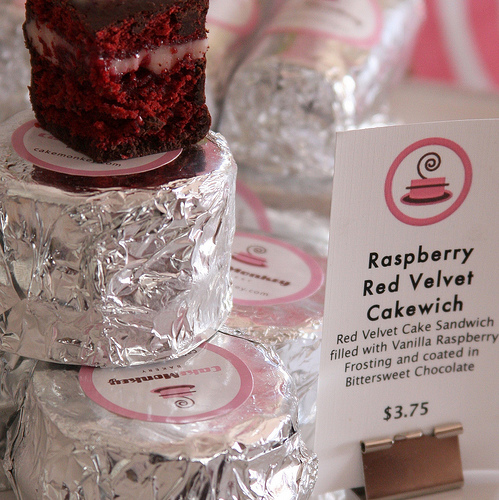<image>
Can you confirm if the cake is in front of the price tag? Yes. The cake is positioned in front of the price tag, appearing closer to the camera viewpoint. 